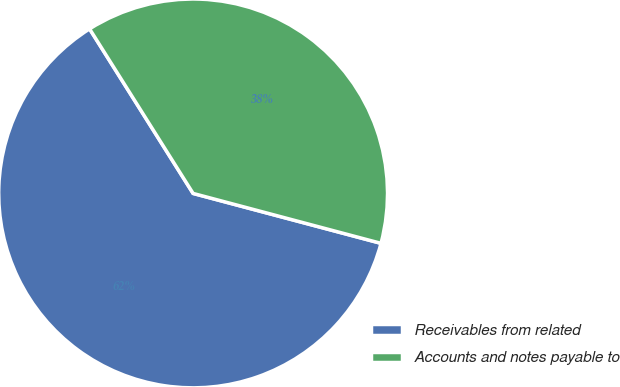<chart> <loc_0><loc_0><loc_500><loc_500><pie_chart><fcel>Receivables from related<fcel>Accounts and notes payable to<nl><fcel>61.93%<fcel>38.07%<nl></chart> 